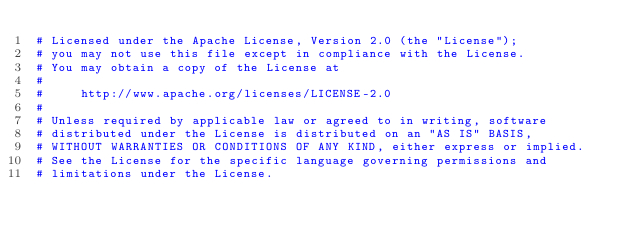Convert code to text. <code><loc_0><loc_0><loc_500><loc_500><_Python_># Licensed under the Apache License, Version 2.0 (the "License");
# you may not use this file except in compliance with the License.
# You may obtain a copy of the License at
#
#     http://www.apache.org/licenses/LICENSE-2.0
#
# Unless required by applicable law or agreed to in writing, software
# distributed under the License is distributed on an "AS IS" BASIS,
# WITHOUT WARRANTIES OR CONDITIONS OF ANY KIND, either express or implied.
# See the License for the specific language governing permissions and
# limitations under the License.</code> 